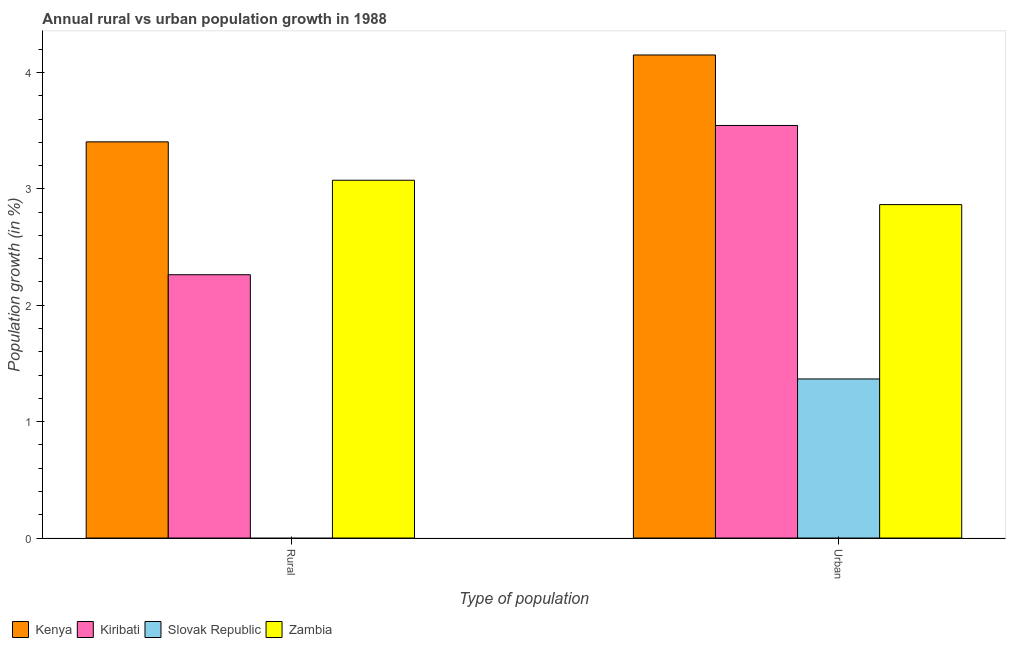How many bars are there on the 1st tick from the left?
Keep it short and to the point. 3. What is the label of the 1st group of bars from the left?
Offer a terse response. Rural. What is the rural population growth in Kiribati?
Keep it short and to the point. 2.26. Across all countries, what is the maximum rural population growth?
Provide a short and direct response. 3.4. Across all countries, what is the minimum urban population growth?
Give a very brief answer. 1.37. In which country was the rural population growth maximum?
Offer a very short reply. Kenya. What is the total urban population growth in the graph?
Your response must be concise. 11.93. What is the difference between the urban population growth in Kenya and that in Slovak Republic?
Offer a terse response. 2.78. What is the difference between the urban population growth in Kenya and the rural population growth in Slovak Republic?
Offer a terse response. 4.15. What is the average urban population growth per country?
Your response must be concise. 2.98. What is the difference between the urban population growth and rural population growth in Zambia?
Ensure brevity in your answer.  -0.21. In how many countries, is the urban population growth greater than 3.8 %?
Your answer should be very brief. 1. What is the ratio of the urban population growth in Slovak Republic to that in Kiribati?
Your response must be concise. 0.39. Is the rural population growth in Zambia less than that in Kenya?
Make the answer very short. Yes. In how many countries, is the rural population growth greater than the average rural population growth taken over all countries?
Provide a short and direct response. 3. How many countries are there in the graph?
Your answer should be compact. 4. Does the graph contain any zero values?
Keep it short and to the point. Yes. Where does the legend appear in the graph?
Provide a short and direct response. Bottom left. How are the legend labels stacked?
Keep it short and to the point. Horizontal. What is the title of the graph?
Your answer should be very brief. Annual rural vs urban population growth in 1988. Does "Tunisia" appear as one of the legend labels in the graph?
Your answer should be very brief. No. What is the label or title of the X-axis?
Your answer should be compact. Type of population. What is the label or title of the Y-axis?
Provide a short and direct response. Population growth (in %). What is the Population growth (in %) in Kenya in Rural?
Ensure brevity in your answer.  3.4. What is the Population growth (in %) in Kiribati in Rural?
Keep it short and to the point. 2.26. What is the Population growth (in %) of Zambia in Rural?
Offer a terse response. 3.07. What is the Population growth (in %) in Kenya in Urban ?
Provide a short and direct response. 4.15. What is the Population growth (in %) in Kiribati in Urban ?
Provide a succinct answer. 3.54. What is the Population growth (in %) in Slovak Republic in Urban ?
Provide a succinct answer. 1.37. What is the Population growth (in %) of Zambia in Urban ?
Keep it short and to the point. 2.86. Across all Type of population, what is the maximum Population growth (in %) of Kenya?
Provide a short and direct response. 4.15. Across all Type of population, what is the maximum Population growth (in %) of Kiribati?
Keep it short and to the point. 3.54. Across all Type of population, what is the maximum Population growth (in %) of Slovak Republic?
Your response must be concise. 1.37. Across all Type of population, what is the maximum Population growth (in %) in Zambia?
Your answer should be compact. 3.07. Across all Type of population, what is the minimum Population growth (in %) in Kenya?
Provide a short and direct response. 3.4. Across all Type of population, what is the minimum Population growth (in %) of Kiribati?
Offer a very short reply. 2.26. Across all Type of population, what is the minimum Population growth (in %) of Slovak Republic?
Offer a very short reply. 0. Across all Type of population, what is the minimum Population growth (in %) in Zambia?
Provide a short and direct response. 2.86. What is the total Population growth (in %) in Kenya in the graph?
Your answer should be very brief. 7.55. What is the total Population growth (in %) in Kiribati in the graph?
Offer a very short reply. 5.81. What is the total Population growth (in %) of Slovak Republic in the graph?
Ensure brevity in your answer.  1.37. What is the total Population growth (in %) of Zambia in the graph?
Provide a succinct answer. 5.94. What is the difference between the Population growth (in %) in Kenya in Rural and that in Urban ?
Provide a short and direct response. -0.75. What is the difference between the Population growth (in %) in Kiribati in Rural and that in Urban ?
Make the answer very short. -1.28. What is the difference between the Population growth (in %) in Zambia in Rural and that in Urban ?
Offer a very short reply. 0.21. What is the difference between the Population growth (in %) of Kenya in Rural and the Population growth (in %) of Kiribati in Urban?
Your answer should be very brief. -0.14. What is the difference between the Population growth (in %) of Kenya in Rural and the Population growth (in %) of Slovak Republic in Urban?
Your answer should be very brief. 2.04. What is the difference between the Population growth (in %) in Kenya in Rural and the Population growth (in %) in Zambia in Urban?
Provide a succinct answer. 0.54. What is the difference between the Population growth (in %) of Kiribati in Rural and the Population growth (in %) of Slovak Republic in Urban?
Make the answer very short. 0.9. What is the difference between the Population growth (in %) of Kiribati in Rural and the Population growth (in %) of Zambia in Urban?
Give a very brief answer. -0.6. What is the average Population growth (in %) of Kenya per Type of population?
Ensure brevity in your answer.  3.78. What is the average Population growth (in %) of Kiribati per Type of population?
Give a very brief answer. 2.9. What is the average Population growth (in %) in Slovak Republic per Type of population?
Give a very brief answer. 0.68. What is the average Population growth (in %) in Zambia per Type of population?
Ensure brevity in your answer.  2.97. What is the difference between the Population growth (in %) of Kenya and Population growth (in %) of Kiribati in Rural?
Provide a short and direct response. 1.14. What is the difference between the Population growth (in %) of Kenya and Population growth (in %) of Zambia in Rural?
Offer a very short reply. 0.33. What is the difference between the Population growth (in %) in Kiribati and Population growth (in %) in Zambia in Rural?
Your response must be concise. -0.81. What is the difference between the Population growth (in %) in Kenya and Population growth (in %) in Kiribati in Urban ?
Make the answer very short. 0.61. What is the difference between the Population growth (in %) of Kenya and Population growth (in %) of Slovak Republic in Urban ?
Make the answer very short. 2.78. What is the difference between the Population growth (in %) of Kenya and Population growth (in %) of Zambia in Urban ?
Keep it short and to the point. 1.29. What is the difference between the Population growth (in %) of Kiribati and Population growth (in %) of Slovak Republic in Urban ?
Make the answer very short. 2.18. What is the difference between the Population growth (in %) of Kiribati and Population growth (in %) of Zambia in Urban ?
Your response must be concise. 0.68. What is the difference between the Population growth (in %) of Slovak Republic and Population growth (in %) of Zambia in Urban ?
Offer a terse response. -1.5. What is the ratio of the Population growth (in %) of Kenya in Rural to that in Urban ?
Keep it short and to the point. 0.82. What is the ratio of the Population growth (in %) in Kiribati in Rural to that in Urban ?
Your answer should be very brief. 0.64. What is the ratio of the Population growth (in %) of Zambia in Rural to that in Urban ?
Offer a very short reply. 1.07. What is the difference between the highest and the second highest Population growth (in %) in Kenya?
Offer a terse response. 0.75. What is the difference between the highest and the second highest Population growth (in %) of Kiribati?
Offer a very short reply. 1.28. What is the difference between the highest and the second highest Population growth (in %) of Zambia?
Give a very brief answer. 0.21. What is the difference between the highest and the lowest Population growth (in %) in Kenya?
Make the answer very short. 0.75. What is the difference between the highest and the lowest Population growth (in %) in Kiribati?
Your answer should be very brief. 1.28. What is the difference between the highest and the lowest Population growth (in %) of Slovak Republic?
Make the answer very short. 1.37. What is the difference between the highest and the lowest Population growth (in %) in Zambia?
Ensure brevity in your answer.  0.21. 